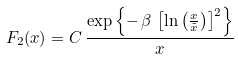Convert formula to latex. <formula><loc_0><loc_0><loc_500><loc_500>F _ { 2 } ( x ) = C \, \frac { \exp \left \{ - \, \beta \, \left [ \ln \left ( \frac { x } { \tilde { x } } \right ) \right ] ^ { 2 } \right \} } { x }</formula> 